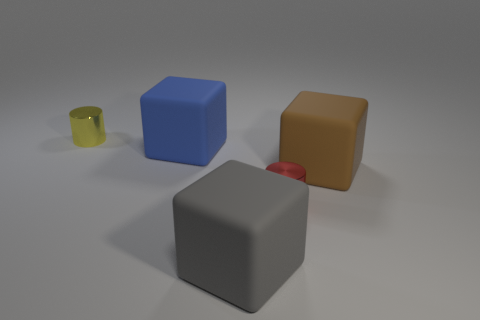Subtract all big blue blocks. How many blocks are left? 2 Add 3 big gray things. How many objects exist? 8 Subtract all blue cubes. How many cubes are left? 2 Subtract all brown cylinders. Subtract all green spheres. How many cylinders are left? 2 Add 3 yellow cubes. How many yellow cubes exist? 3 Subtract 0 blue spheres. How many objects are left? 5 Subtract all cylinders. How many objects are left? 3 Subtract all yellow cylinders. Subtract all blue blocks. How many objects are left? 3 Add 3 yellow metallic objects. How many yellow metallic objects are left? 4 